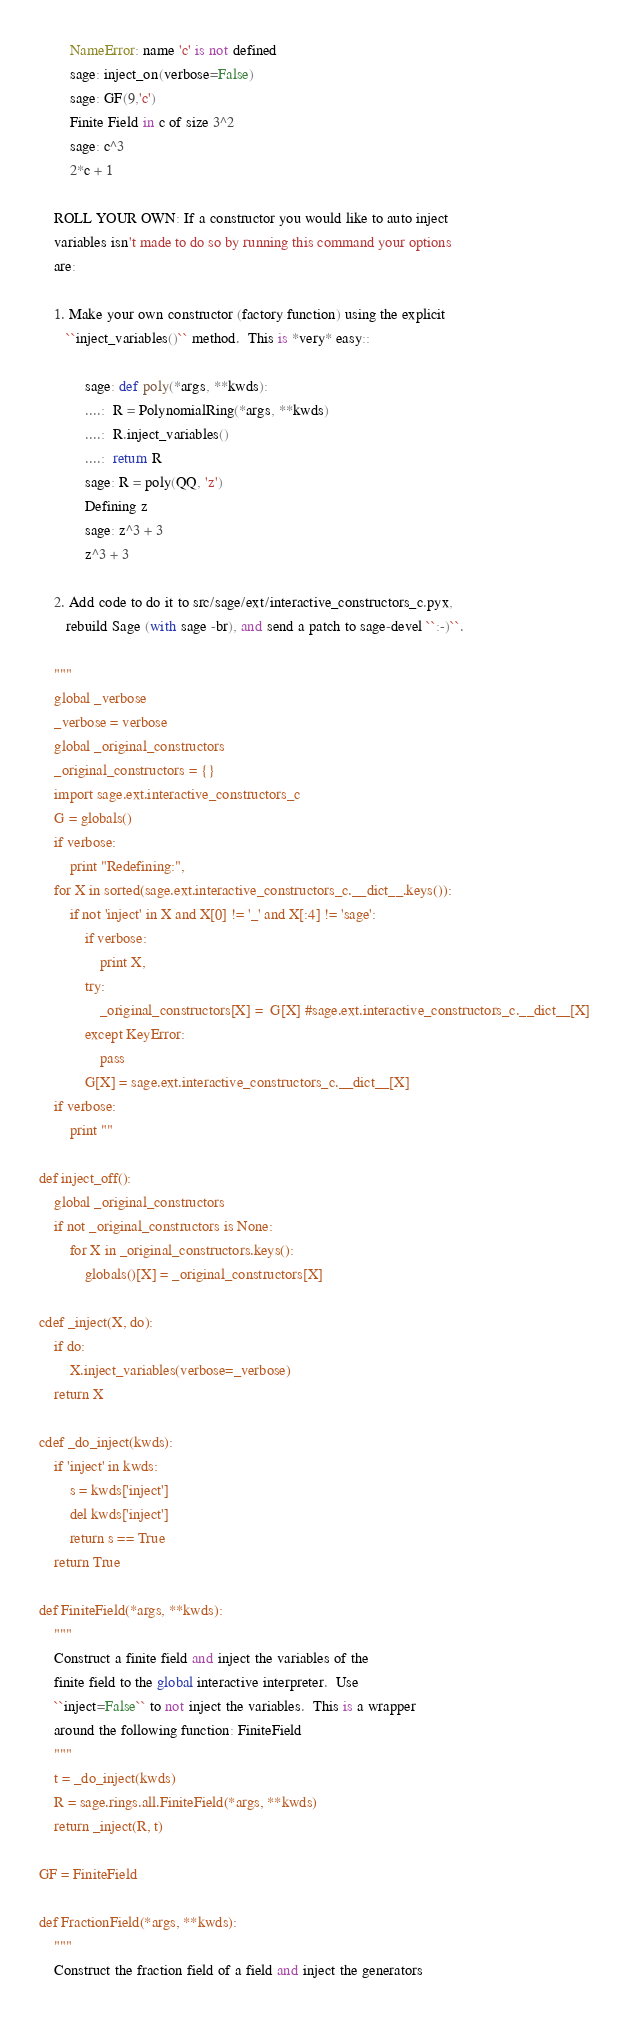<code> <loc_0><loc_0><loc_500><loc_500><_Cython_>        NameError: name 'c' is not defined
        sage: inject_on(verbose=False)
        sage: GF(9,'c')
        Finite Field in c of size 3^2
        sage: c^3
        2*c + 1

    ROLL YOUR OWN: If a constructor you would like to auto inject
    variables isn't made to do so by running this command your options
    are:

    1. Make your own constructor (factory function) using the explicit
       ``inject_variables()`` method.  This is *very* easy::

            sage: def poly(*args, **kwds):
            ....:  R = PolynomialRing(*args, **kwds)
            ....:  R.inject_variables()
            ....:  return R
            sage: R = poly(QQ, 'z')
            Defining z
            sage: z^3 + 3
            z^3 + 3

    2. Add code to do it to src/sage/ext/interactive_constructors_c.pyx,
       rebuild Sage (with sage -br), and send a patch to sage-devel ``:-)``.

    """
    global _verbose
    _verbose = verbose
    global _original_constructors
    _original_constructors = {}
    import sage.ext.interactive_constructors_c
    G = globals()
    if verbose:
        print "Redefining:",
    for X in sorted(sage.ext.interactive_constructors_c.__dict__.keys()):
        if not 'inject' in X and X[0] != '_' and X[:4] != 'sage':
            if verbose:
                print X,
            try:
                _original_constructors[X] =  G[X] #sage.ext.interactive_constructors_c.__dict__[X]
            except KeyError:
                pass
            G[X] = sage.ext.interactive_constructors_c.__dict__[X]
    if verbose:
        print ""

def inject_off():
    global _original_constructors
    if not _original_constructors is None:
        for X in _original_constructors.keys():
            globals()[X] = _original_constructors[X]

cdef _inject(X, do):
    if do:
        X.inject_variables(verbose=_verbose)
    return X

cdef _do_inject(kwds):
    if 'inject' in kwds:
        s = kwds['inject']
        del kwds['inject']
        return s == True
    return True

def FiniteField(*args, **kwds):
    """
    Construct a finite field and inject the variables of the
    finite field to the global interactive interpreter.  Use
    ``inject=False`` to not inject the variables.  This is a wrapper
    around the following function: FiniteField
    """
    t = _do_inject(kwds)
    R = sage.rings.all.FiniteField(*args, **kwds)
    return _inject(R, t)

GF = FiniteField

def FractionField(*args, **kwds):
    """
    Construct the fraction field of a field and inject the generators</code> 